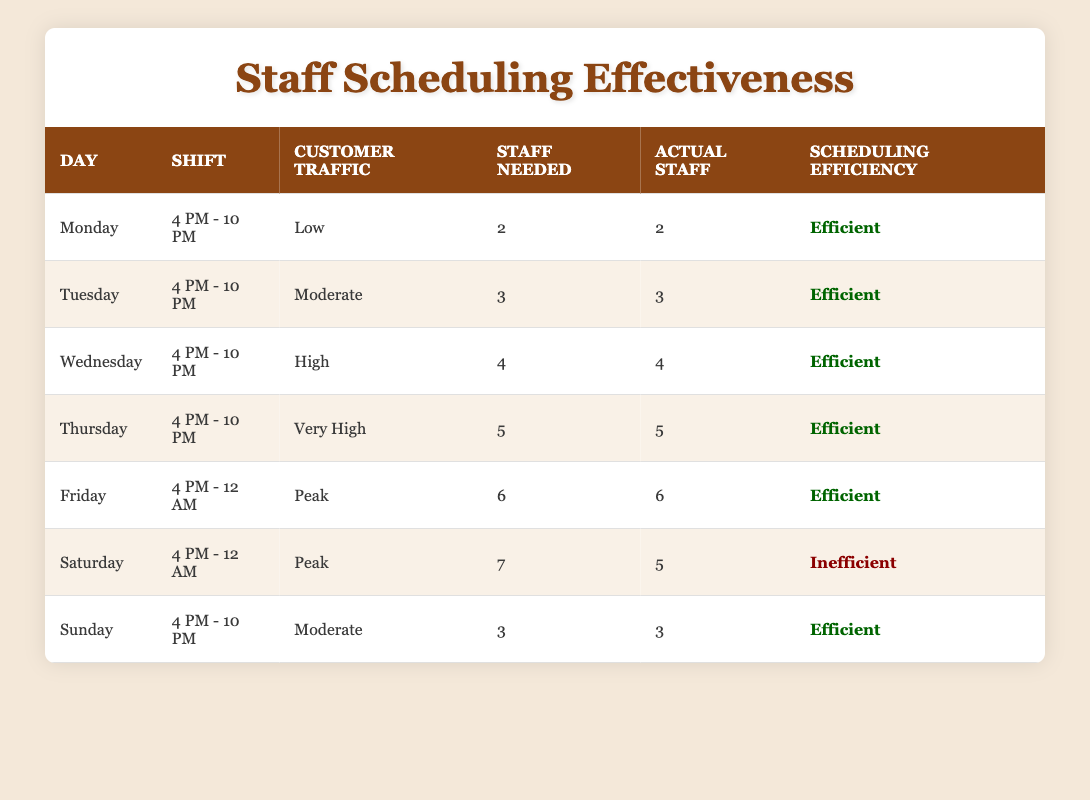What day had the highest staff needed according to the table? Thursday had the highest staff needed at 5 based on its customer traffic of Very High.
Answer: Thursday Is the scheduling efficiency on Saturday efficient or inefficient? The scheduling efficiency on Saturday is Inefficient as the actual staff (5) is less than the staff needed (7).
Answer: Inefficient What is the total staff needed from Monday to Friday? Adding the staff needed from Monday (2), Tuesday (3), Wednesday (4), Thursday (5), and Friday (6) gives a total of 2 + 3 + 4 + 5 + 6 = 20.
Answer: 20 On which day do we need the least staff? Monday needs the least staff, requiring only 2 based on its low customer traffic.
Answer: Monday Is it true that all days except Saturday have an efficient scheduling efficiency? Yes, it's true. All days except Saturday show an efficient scheduling efficiency, as they match the actual staff with the staff needed.
Answer: Yes What is the average staff needed for the days with peak customer traffic? Friday and Saturday have peak traffic, needing 6 and 7 staff, respectively. The average is (6 + 7) / 2 = 6.5.
Answer: 6.5 Which day shows a scheduling efficiency classified as efficient? Every day except Saturday shows scheduling efficiency classified as Efficient.
Answer: Monday, Tuesday, Wednesday, Thursday, Friday, Sunday How many staff were actually needed on Sunday, and was it sufficient? On Sunday, 3 staff were needed and 3 staff were present, therefore it was sufficient.
Answer: 3 staff, sufficient What percentage of the days had scheduling efficiencies classified as inefficient? Out of 7 days, only 1 day (Saturday) was inefficient, making it (1/7)*100% = about 14.29%.
Answer: 14.29% 